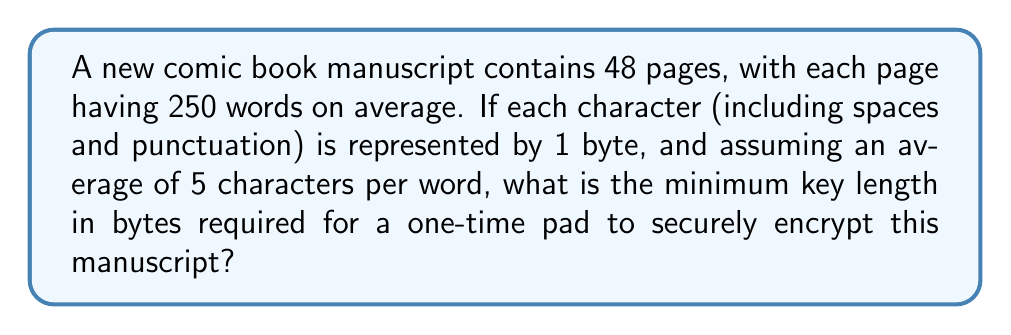Could you help me with this problem? To determine the key length for a one-time pad, we need to calculate the total number of bytes in the manuscript. Let's break this down step-by-step:

1. Calculate the total number of words:
   $$ \text{Total words} = 48 \text{ pages} \times 250 \text{ words/page} = 12,000 \text{ words} $$

2. Calculate the total number of characters:
   $$ \text{Total characters} = 12,000 \text{ words} \times 5 \text{ characters/word} = 60,000 \text{ characters} $$

3. Since each character is represented by 1 byte:
   $$ \text{Total bytes} = 60,000 \text{ characters} \times 1 \text{ byte/character} = 60,000 \text{ bytes} $$

4. For a one-time pad to be secure, the key must be:
   a) As long as the plaintext
   b) Truly random
   c) Used only once

Therefore, the minimum key length required is equal to the total number of bytes in the manuscript: 60,000 bytes.
Answer: 60,000 bytes 